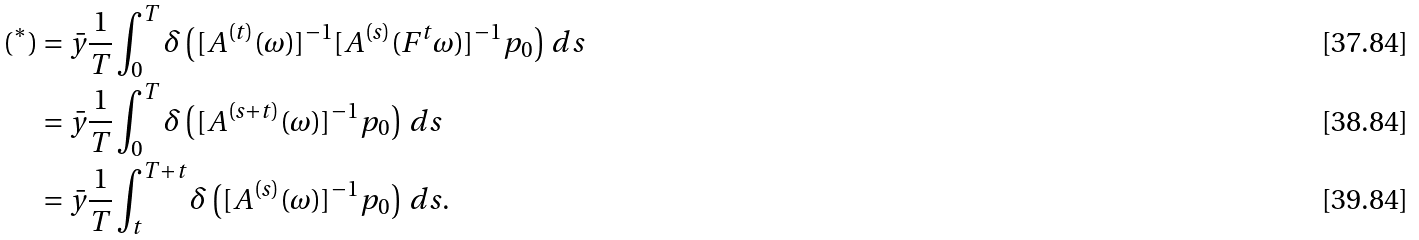<formula> <loc_0><loc_0><loc_500><loc_500>( ^ { * } ) & = \bar { y } \frac { 1 } { T } \int _ { 0 } ^ { T } \delta \left ( [ A ^ { ( t ) } ( \omega ) ] ^ { - 1 } [ A ^ { ( s ) } ( F ^ { t } \omega ) ] ^ { - 1 } p _ { 0 } \right ) \, d s \\ & = \bar { y } \frac { 1 } { T } \int _ { 0 } ^ { T } \delta \left ( [ A ^ { ( s + t ) } ( \omega ) ] ^ { - 1 } p _ { 0 } \right ) \, d s \\ & = \bar { y } \frac { 1 } { T } \int _ { t } ^ { T + t } \delta \left ( [ A ^ { ( s ) } ( \omega ) ] ^ { - 1 } p _ { 0 } \right ) \, d s .</formula> 